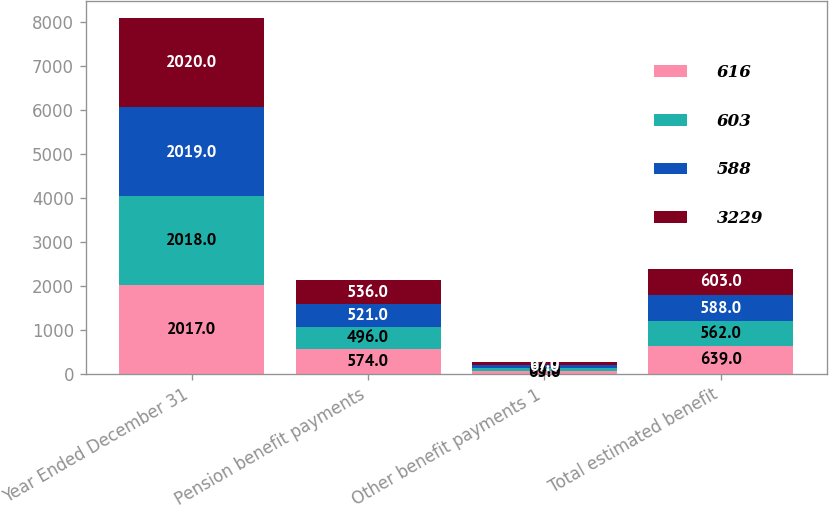<chart> <loc_0><loc_0><loc_500><loc_500><stacked_bar_chart><ecel><fcel>Year Ended December 31<fcel>Pension benefit payments<fcel>Other benefit payments 1<fcel>Total estimated benefit<nl><fcel>616<fcel>2017<fcel>574<fcel>65<fcel>639<nl><fcel>603<fcel>2018<fcel>496<fcel>66<fcel>562<nl><fcel>588<fcel>2019<fcel>521<fcel>67<fcel>588<nl><fcel>3229<fcel>2020<fcel>536<fcel>67<fcel>603<nl></chart> 